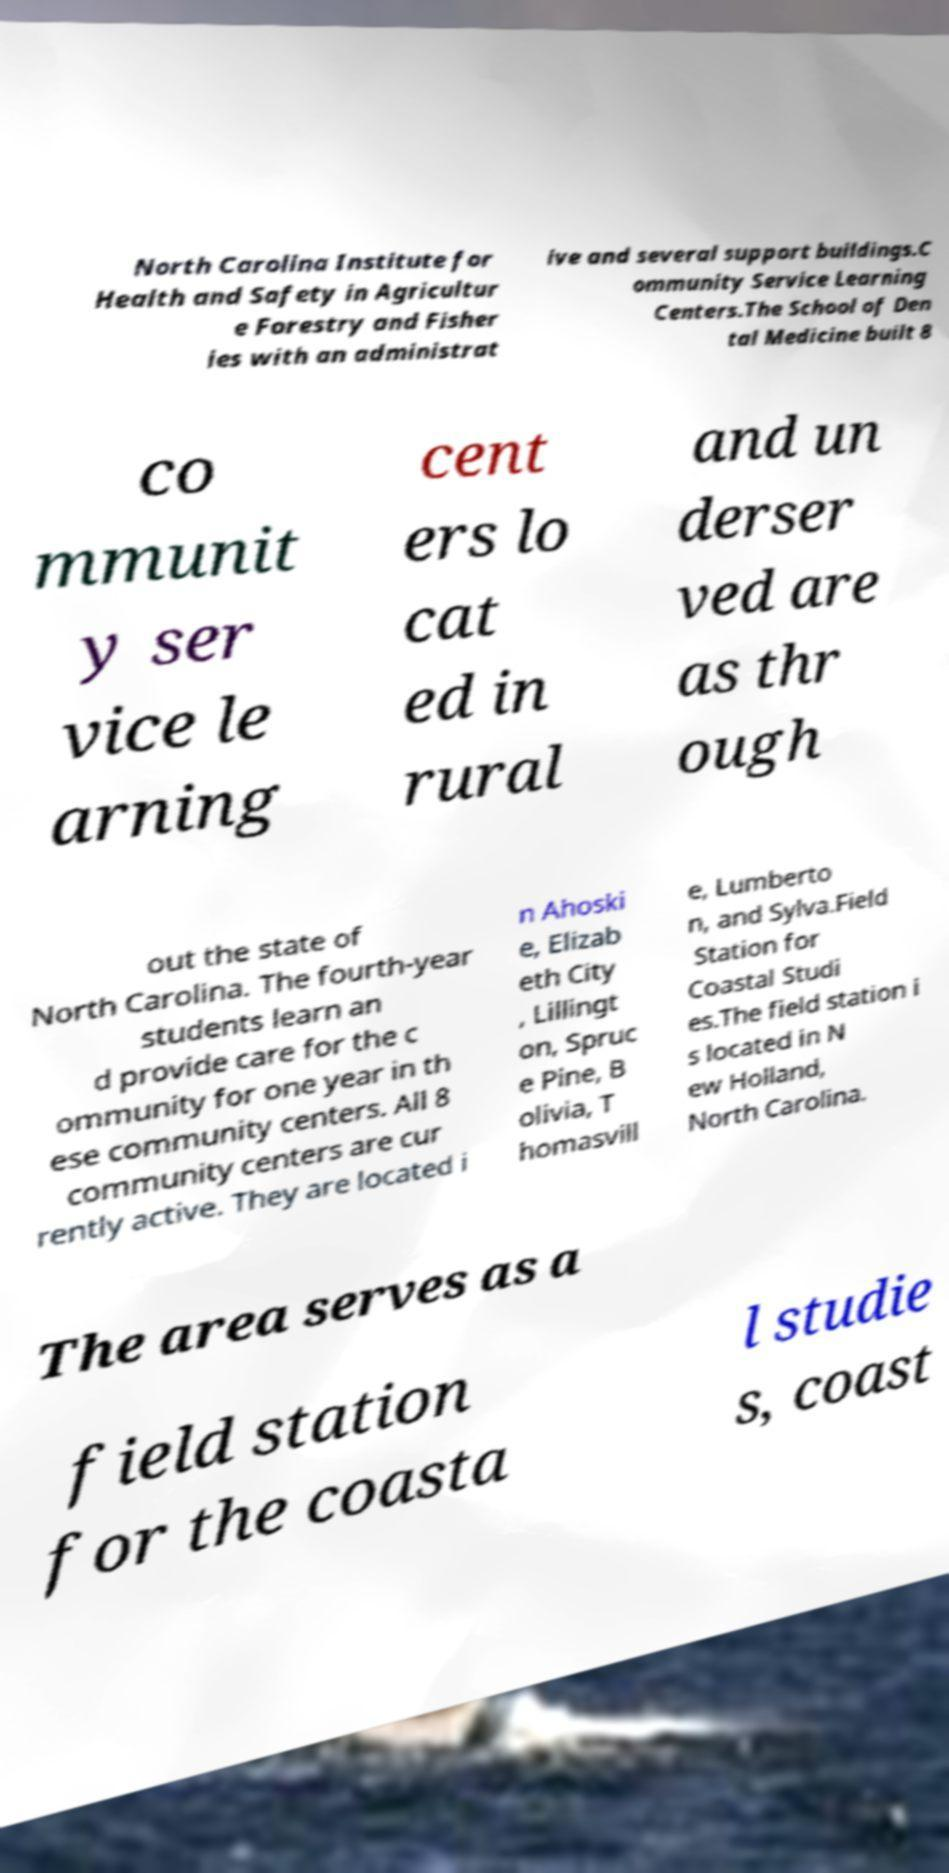Please read and relay the text visible in this image. What does it say? North Carolina Institute for Health and Safety in Agricultur e Forestry and Fisher ies with an administrat ive and several support buildings.C ommunity Service Learning Centers.The School of Den tal Medicine built 8 co mmunit y ser vice le arning cent ers lo cat ed in rural and un derser ved are as thr ough out the state of North Carolina. The fourth-year students learn an d provide care for the c ommunity for one year in th ese community centers. All 8 community centers are cur rently active. They are located i n Ahoski e, Elizab eth City , Lillingt on, Spruc e Pine, B olivia, T homasvill e, Lumberto n, and Sylva.Field Station for Coastal Studi es.The field station i s located in N ew Holland, North Carolina. The area serves as a field station for the coasta l studie s, coast 